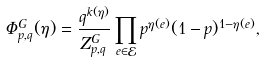<formula> <loc_0><loc_0><loc_500><loc_500>\Phi ^ { G } _ { p , q } ( \eta ) = \frac { q ^ { k ( \eta ) } } { Z ^ { G } _ { p , q } } \prod _ { e \in \mathcal { E } } p ^ { \eta ( e ) } ( 1 - p ) ^ { 1 - \eta ( e ) } ,</formula> 